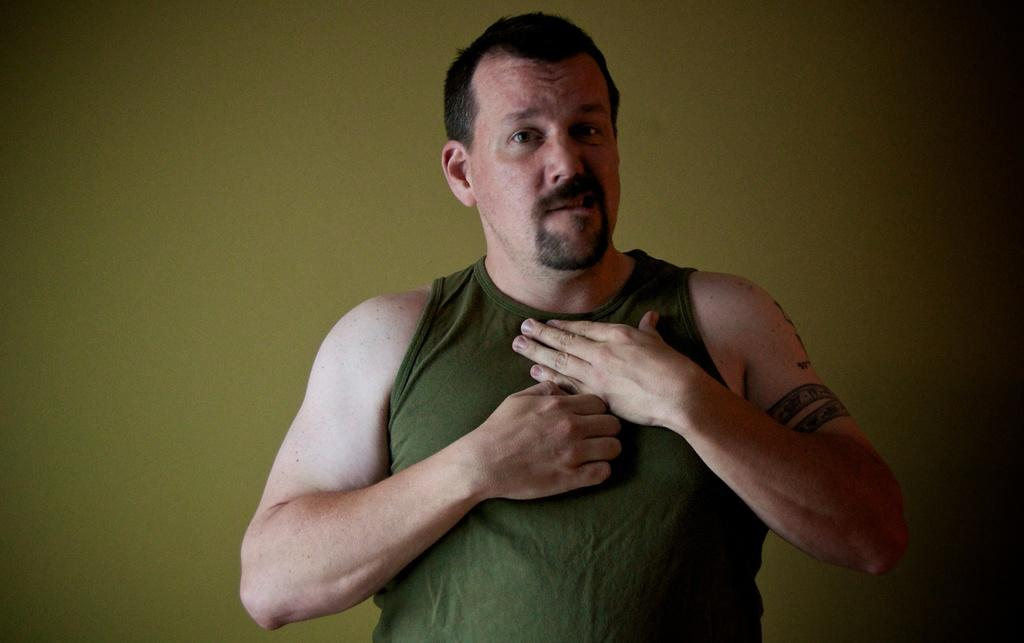What is the main subject of the image? There is a person standing in the image. What is the person wearing in the image? The person is wearing a gray color top. Where is the person located in the image? The person is in the middle of the image. What can be seen in the background of the image? There is a green color wall in the background of the image. How many cattle are visible in the image? There are no cattle present in the image; it features a person standing in front of a green color wall. Can you tell me which vein the person is using to stand in the image? The image does not provide information about the person's veins or how they are standing. 